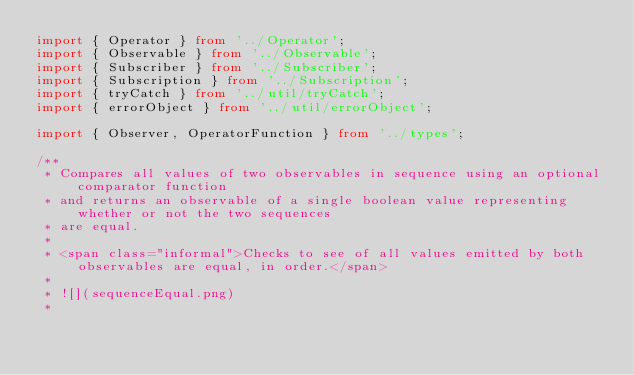<code> <loc_0><loc_0><loc_500><loc_500><_TypeScript_>import { Operator } from '../Operator';
import { Observable } from '../Observable';
import { Subscriber } from '../Subscriber';
import { Subscription } from '../Subscription';
import { tryCatch } from '../util/tryCatch';
import { errorObject } from '../util/errorObject';

import { Observer, OperatorFunction } from '../types';

/**
 * Compares all values of two observables in sequence using an optional comparator function
 * and returns an observable of a single boolean value representing whether or not the two sequences
 * are equal.
 *
 * <span class="informal">Checks to see of all values emitted by both observables are equal, in order.</span>
 *
 * ![](sequenceEqual.png)
 *</code> 